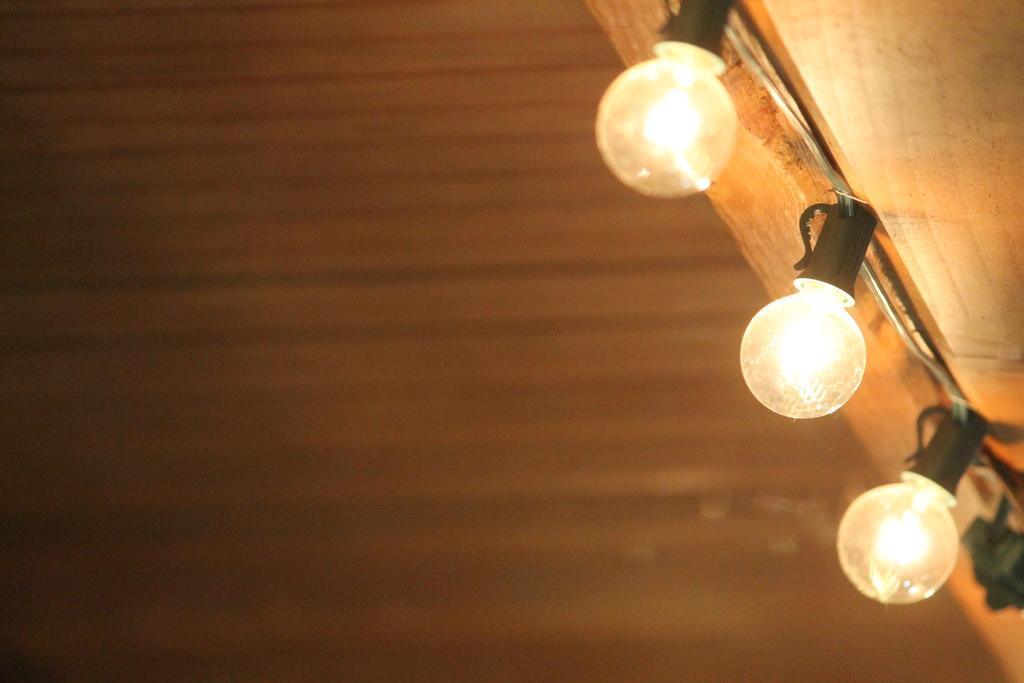What can be seen in the image that provides illumination? There are lights in the image. What is the appearance of the background in the image? The background of the image is blurred. What type of glove is being discussed in the image? There is no glove present in the image. What news event is being reported in the image? There is no news event being reported in the image. Is there any indication of regret in the image? There is no indication of regret in the image. 